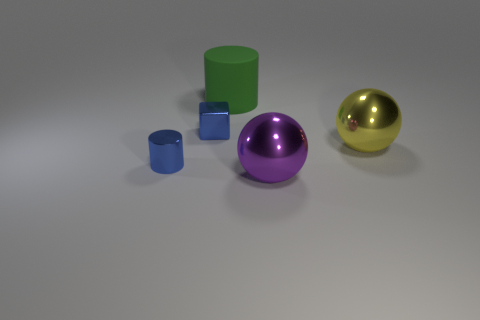How many other things are the same color as the shiny cylinder?
Keep it short and to the point. 1. How many other small cylinders are the same material as the small cylinder?
Your answer should be compact. 0. What number of objects are yellow things or green rubber objects?
Make the answer very short. 2. Is there a purple thing?
Give a very brief answer. Yes. There is a cylinder on the left side of the tiny blue metallic thing behind the cylinder in front of the large rubber cylinder; what is it made of?
Provide a short and direct response. Metal. Are there fewer large yellow metallic objects on the left side of the big matte cylinder than large green things?
Provide a succinct answer. Yes. There is a blue cube that is the same size as the blue shiny cylinder; what is its material?
Ensure brevity in your answer.  Metal. There is a metal object that is both to the left of the big yellow metal object and right of the big green cylinder; what size is it?
Provide a succinct answer. Large. There is a shiny object that is the same shape as the green rubber thing; what size is it?
Your response must be concise. Small. How many objects are tiny red matte things or spheres in front of the large yellow object?
Your answer should be compact. 1. 